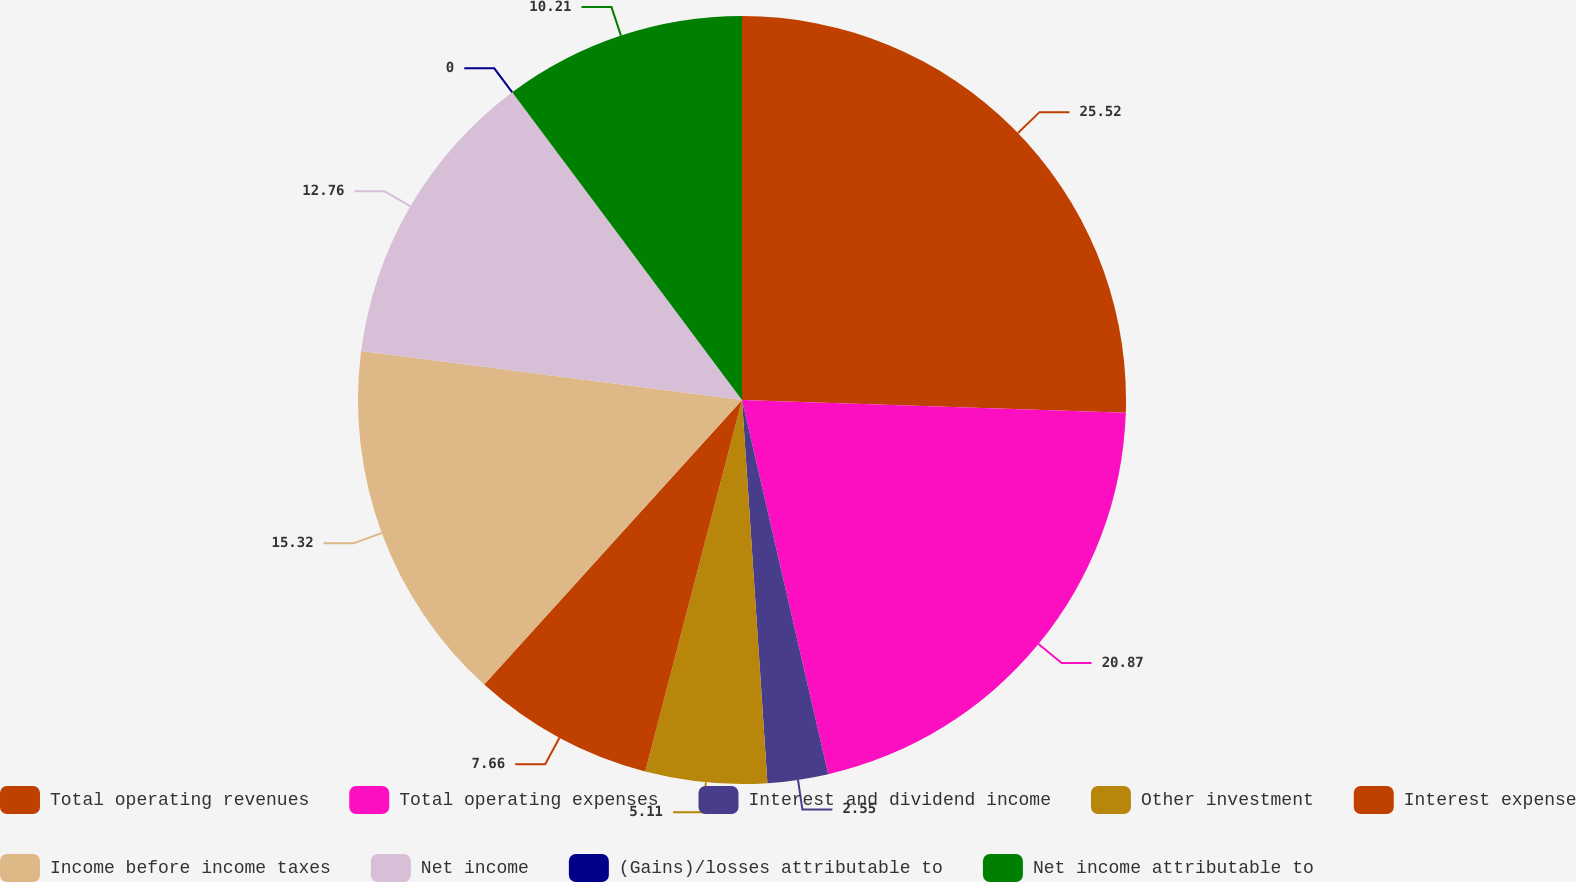Convert chart to OTSL. <chart><loc_0><loc_0><loc_500><loc_500><pie_chart><fcel>Total operating revenues<fcel>Total operating expenses<fcel>Interest and dividend income<fcel>Other investment<fcel>Interest expense<fcel>Income before income taxes<fcel>Net income<fcel>(Gains)/losses attributable to<fcel>Net income attributable to<nl><fcel>25.53%<fcel>20.87%<fcel>2.55%<fcel>5.11%<fcel>7.66%<fcel>15.32%<fcel>12.76%<fcel>0.0%<fcel>10.21%<nl></chart> 